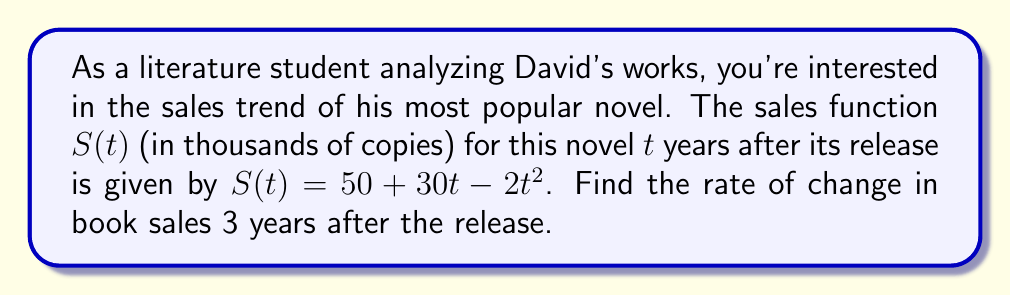Solve this math problem. To find the rate of change in book sales at a specific time, we need to calculate the derivative of the sales function and evaluate it at the given time.

Step 1: Identify the sales function
$S(t) = 50 + 30t - 2t^2$

Step 2: Calculate the derivative of $S(t)$
Using the power rule and constant rule of differentiation:
$\frac{d}{dt}(50) = 0$
$\frac{d}{dt}(30t) = 30$
$\frac{d}{dt}(-2t^2) = -4t$

Combining these terms:
$S'(t) = 30 - 4t$

Step 3: Evaluate $S'(t)$ at $t = 3$ years
$S'(3) = 30 - 4(3) = 30 - 12 = 18$

The rate of change in book sales 3 years after the release is 18 thousand copies per year.
Answer: 18 thousand copies per year 